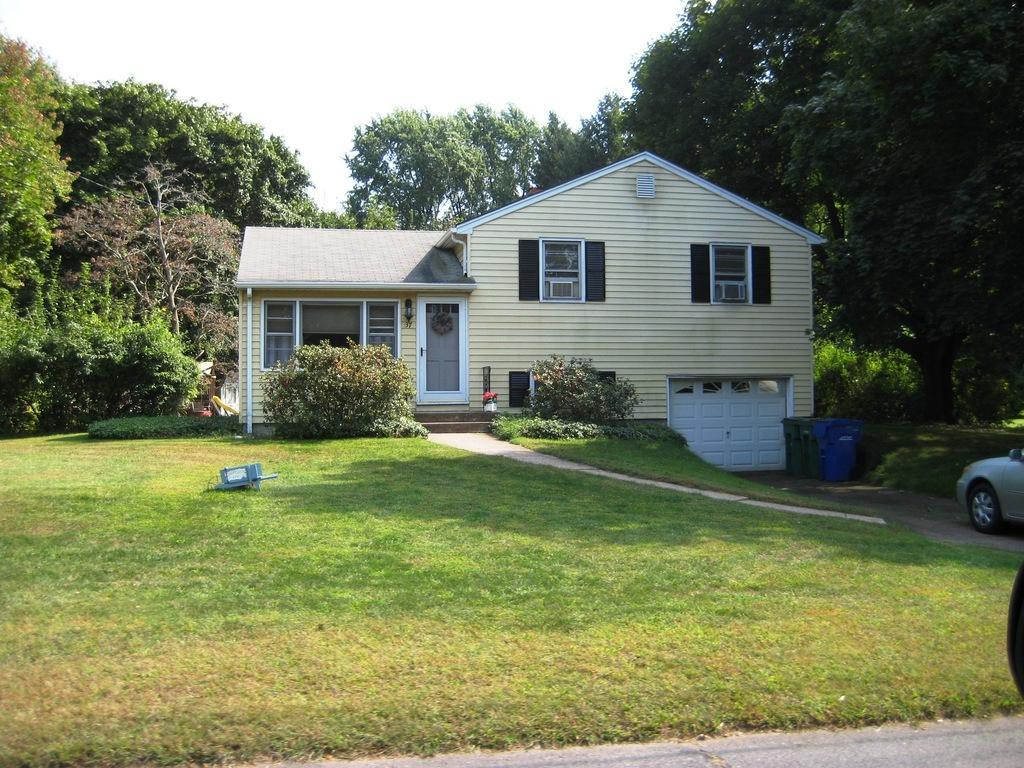Could you give a brief overview of what you see in this image? There is a grass on the ground near a road. On the right side, there is a vehicle on the road. In the background, there is a building which is having glass windows and roof, there are trees and plants on the ground and there is sky. 